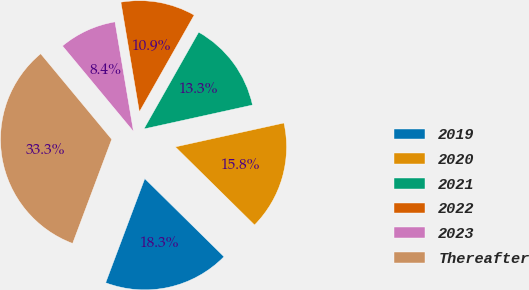<chart> <loc_0><loc_0><loc_500><loc_500><pie_chart><fcel>2019<fcel>2020<fcel>2021<fcel>2022<fcel>2023<fcel>Thereafter<nl><fcel>18.33%<fcel>15.84%<fcel>13.35%<fcel>10.86%<fcel>8.37%<fcel>33.26%<nl></chart> 